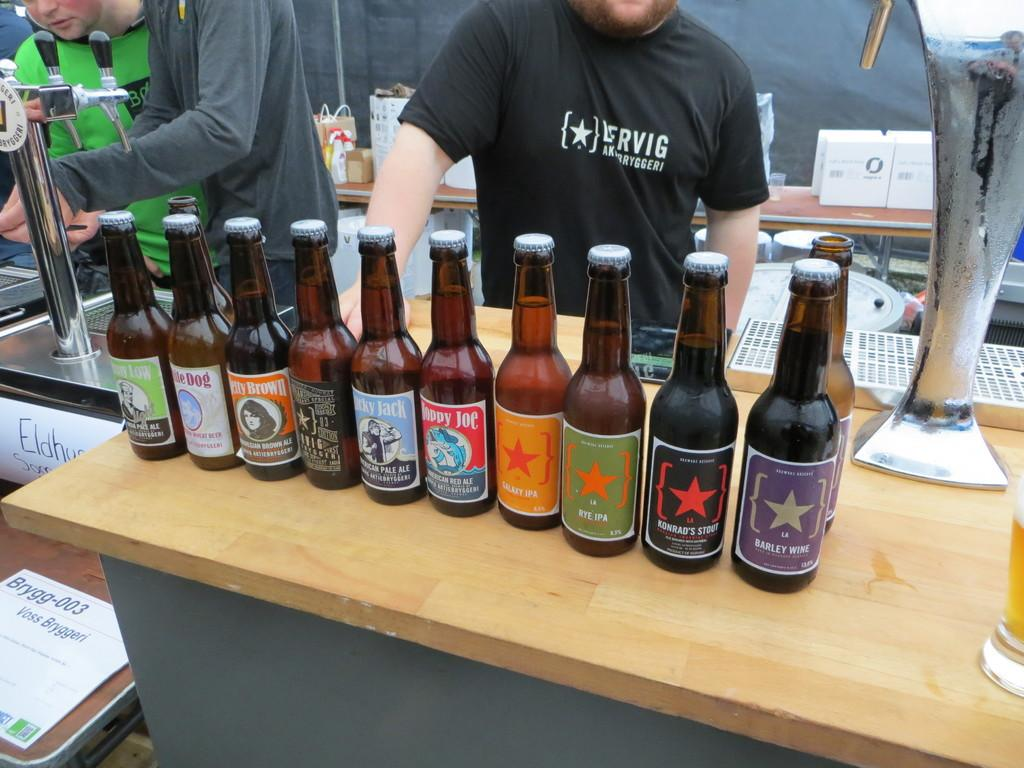<image>
Give a short and clear explanation of the subsequent image. Red bottle of Hoppy Joe American Red Ale in between other beer bottles. 